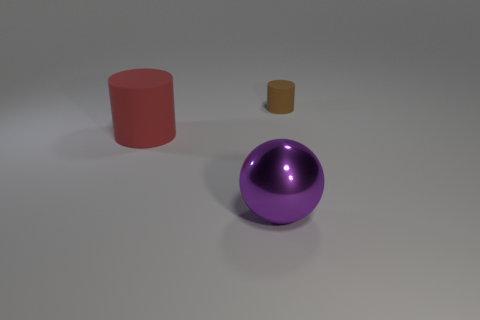Add 1 red rubber cylinders. How many objects exist? 4 Subtract all balls. How many objects are left? 2 Add 1 large metallic things. How many large metallic things exist? 2 Subtract 0 cyan blocks. How many objects are left? 3 Subtract all large blue cylinders. Subtract all small brown objects. How many objects are left? 2 Add 2 tiny things. How many tiny things are left? 3 